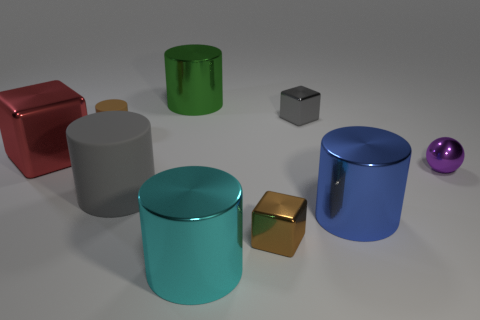Subtract all large blue metallic cylinders. How many cylinders are left? 4 Subtract all cyan cylinders. How many cylinders are left? 4 Subtract all cubes. How many objects are left? 6 Subtract all gray cylinders. Subtract all gray spheres. How many cylinders are left? 4 Add 4 shiny balls. How many shiny balls exist? 5 Subtract 0 blue balls. How many objects are left? 9 Subtract all brown cylinders. Subtract all red blocks. How many objects are left? 7 Add 9 green metal cylinders. How many green metal cylinders are left? 10 